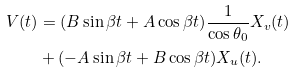Convert formula to latex. <formula><loc_0><loc_0><loc_500><loc_500>V ( t ) & = ( B \sin \beta t + A \cos \beta t ) \frac { 1 } { \cos \theta _ { 0 } } X _ { v } ( t ) \\ & + ( - A \sin \beta t + B \cos \beta t ) X _ { u } ( t ) .</formula> 